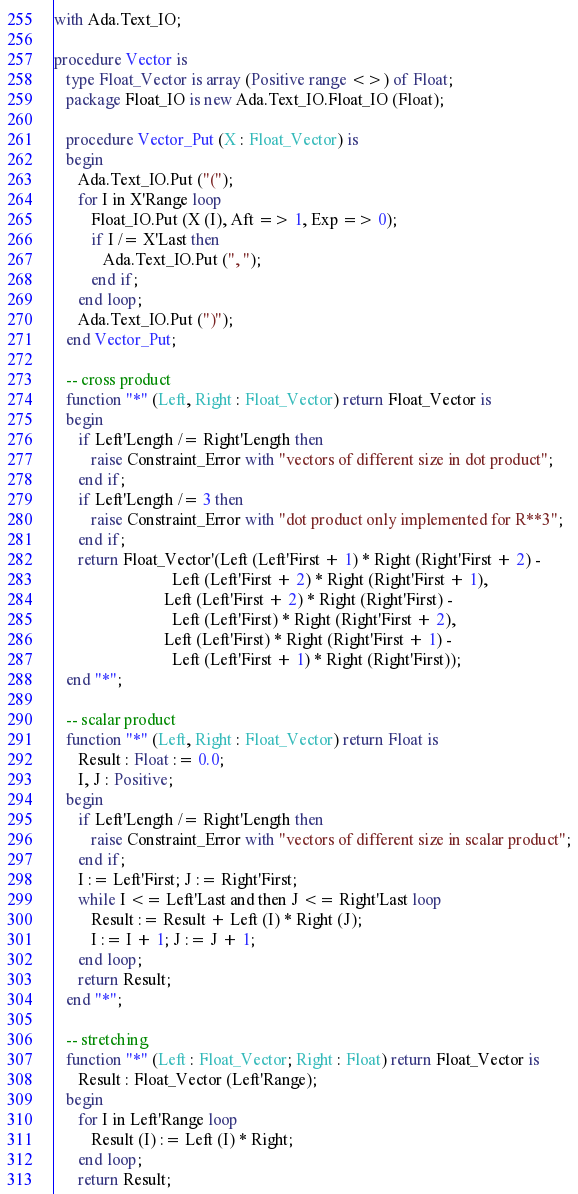Convert code to text. <code><loc_0><loc_0><loc_500><loc_500><_Ada_>with Ada.Text_IO;

procedure Vector is
   type Float_Vector is array (Positive range <>) of Float;
   package Float_IO is new Ada.Text_IO.Float_IO (Float);

   procedure Vector_Put (X : Float_Vector) is
   begin
      Ada.Text_IO.Put ("(");
      for I in X'Range loop
         Float_IO.Put (X (I), Aft => 1, Exp => 0);
         if I /= X'Last then
            Ada.Text_IO.Put (", ");
         end if;
      end loop;
      Ada.Text_IO.Put (")");
   end Vector_Put;

   -- cross product
   function "*" (Left, Right : Float_Vector) return Float_Vector is
   begin
      if Left'Length /= Right'Length then
         raise Constraint_Error with "vectors of different size in dot product";
      end if;
      if Left'Length /= 3 then
         raise Constraint_Error with "dot product only implemented for R**3";
      end if;
      return Float_Vector'(Left (Left'First + 1) * Right (Right'First + 2) -
                             Left (Left'First + 2) * Right (Right'First + 1),
                           Left (Left'First + 2) * Right (Right'First) -
                             Left (Left'First) * Right (Right'First + 2),
                           Left (Left'First) * Right (Right'First + 1) -
                             Left (Left'First + 1) * Right (Right'First));
   end "*";

   -- scalar product
   function "*" (Left, Right : Float_Vector) return Float is
      Result : Float := 0.0;
      I, J : Positive;
   begin
      if Left'Length /= Right'Length then
         raise Constraint_Error with "vectors of different size in scalar product";
      end if;
      I := Left'First; J := Right'First;
      while I <= Left'Last and then J <= Right'Last loop
         Result := Result + Left (I) * Right (J);
         I := I + 1; J := J + 1;
      end loop;
      return Result;
   end "*";

   -- stretching
   function "*" (Left : Float_Vector; Right : Float) return Float_Vector is
      Result : Float_Vector (Left'Range);
   begin
      for I in Left'Range loop
         Result (I) := Left (I) * Right;
      end loop;
      return Result;</code> 